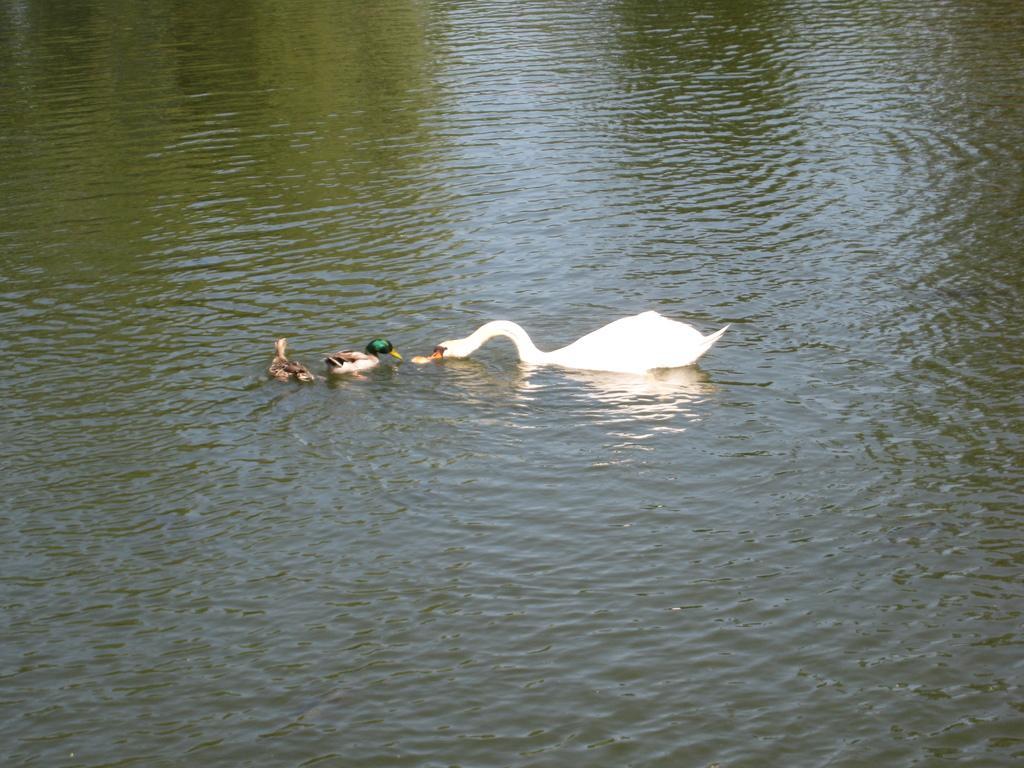Please provide a concise description of this image. In the foreground of this image, there are ducks in the water. 